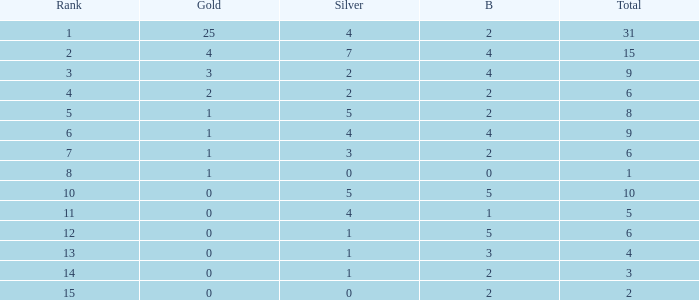What is the highest rank of the medal total less than 15, more than 2 bronzes, 0 gold and 1 silver? 13.0. 